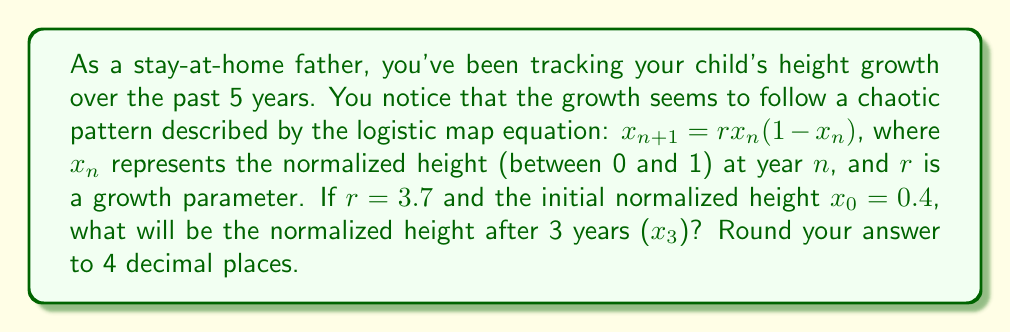Teach me how to tackle this problem. Let's calculate this step-by-step using the logistic map equation:

1) We start with $x_0 = 0.4$ and $r = 3.7$

2) For year 1 ($x_1$):
   $x_1 = rx_0(1-x_0) = 3.7 * 0.4 * (1-0.4) = 3.7 * 0.4 * 0.6 = 0.888$

3) For year 2 ($x_2$):
   $x_2 = rx_1(1-x_1) = 3.7 * 0.888 * (1-0.888) = 3.7 * 0.888 * 0.112 = 0.3682752$

4) For year 3 ($x_3$):
   $x_3 = rx_2(1-x_2) = 3.7 * 0.3682752 * (1-0.3682752)$
        $= 3.7 * 0.3682752 * 0.6317248 = 0.8625500511$

5) Rounding to 4 decimal places: 0.8626

This chaotic growth pattern demonstrates how small changes in initial conditions can lead to significantly different outcomes over time, which is a key characteristic of chaos theory.
Answer: 0.8626 